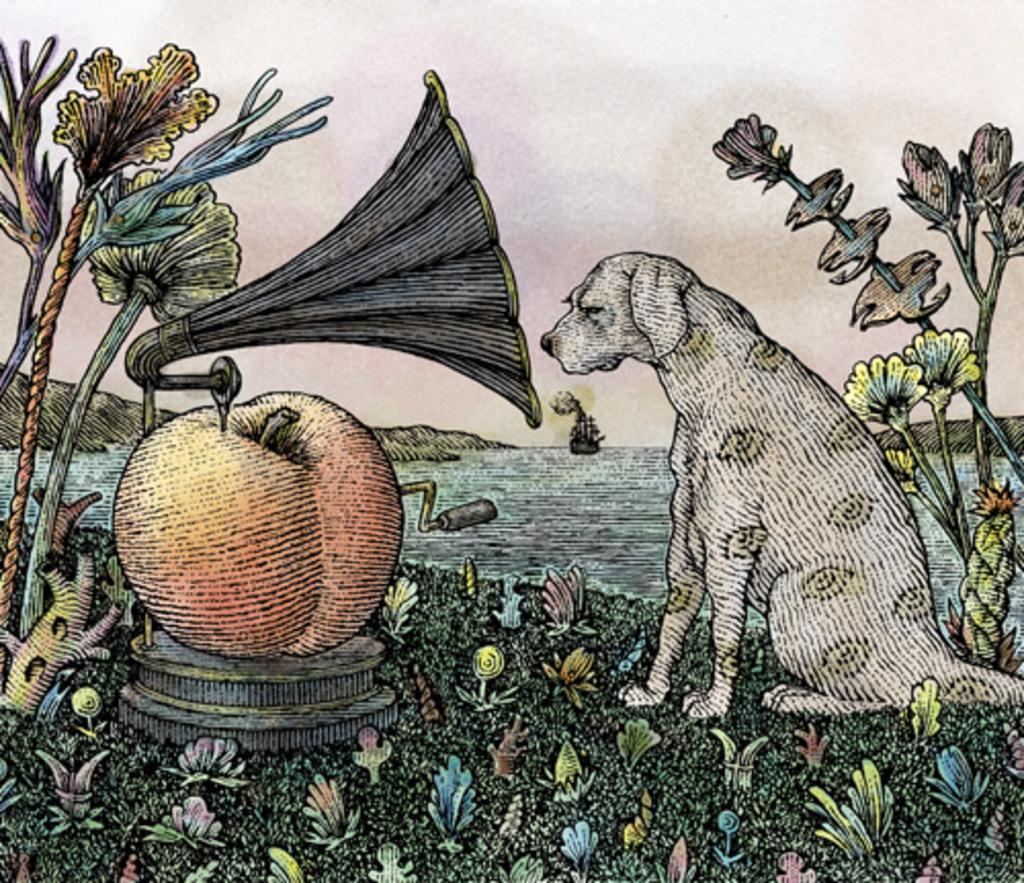Describe this image in one or two sentences. In the center of the image we can see some drawing in different colors, in which we can see one dog, plants, flowers and a few other objects. And we can see one solid structure. On the solid structure, we can see one apple. On the apple, we can see one object. In the background we can see the sky, clouds, water, hills, one boat and a few other objects. 